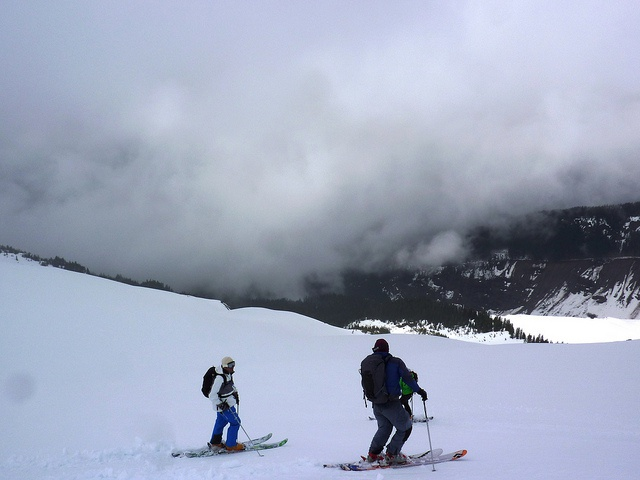Describe the objects in this image and their specific colors. I can see people in darkgray, black, navy, gray, and lavender tones, people in darkgray, black, and navy tones, backpack in darkgray, black, and lavender tones, skis in darkgray and gray tones, and skis in darkgray and gray tones in this image. 